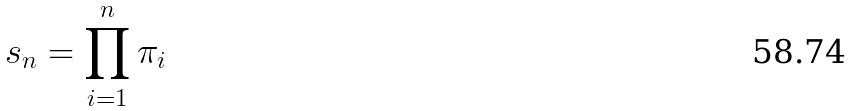<formula> <loc_0><loc_0><loc_500><loc_500>s _ { n } = \prod _ { i = 1 } ^ { n } \pi _ { i }</formula> 